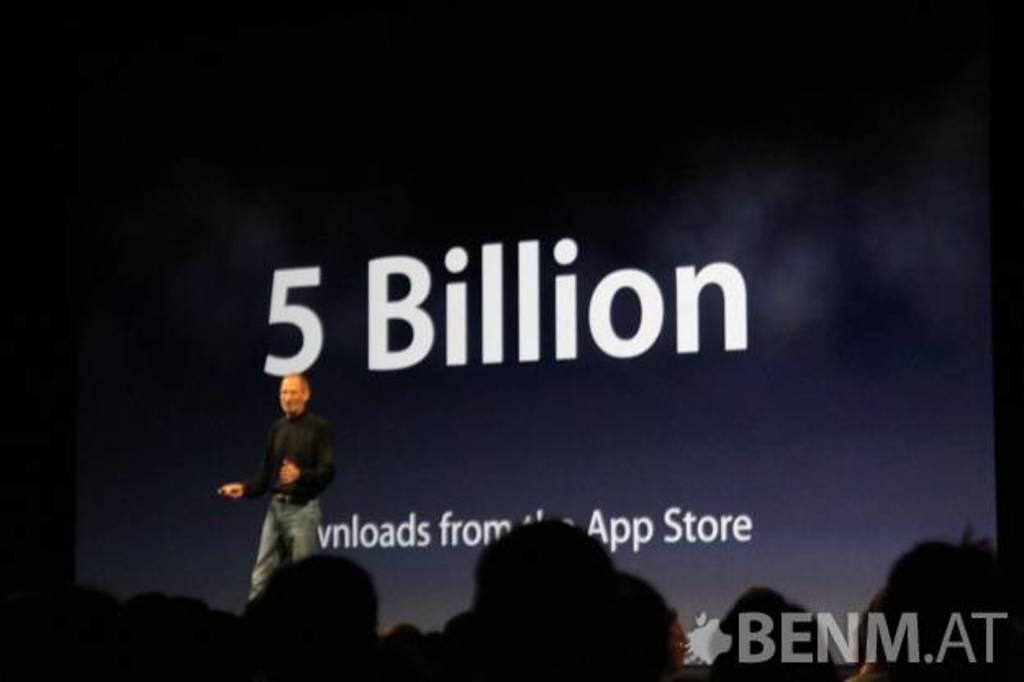What is the main subject of the image? There is a man standing in the image. What can be seen in the background of the image? There is a screen in the background of the image. Are there any other people visible in the image? Yes, there are people visible at the bottom of the image. What is present at the bottom of the image besides the people? There is text present at the bottom of the image. What type of eggnog is being served to the people at the bottom of the image? There is no eggnog present in the image; it only features a man standing, a screen in the background, people, and text at the bottom. 